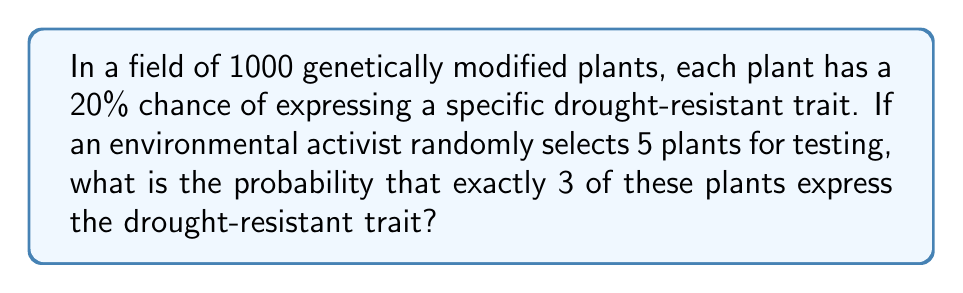Teach me how to tackle this problem. To solve this problem, we can use the binomial probability formula:

$$P(X = k) = \binom{n}{k} p^k (1-p)^{n-k}$$

Where:
$n$ = number of trials (plants selected) = 5
$k$ = number of successes (plants with the trait) = 3
$p$ = probability of success (expressing the trait) = 0.20

Step 1: Calculate the binomial coefficient $\binom{n}{k}$:
$$\binom{5}{3} = \frac{5!}{3!(5-3)!} = \frac{5 \cdot 4}{2 \cdot 1} = 10$$

Step 2: Calculate $p^k$:
$$0.20^3 = 0.008$$

Step 3: Calculate $(1-p)^{n-k}$:
$$(1-0.20)^{5-3} = 0.80^2 = 0.64$$

Step 4: Multiply all components:
$$10 \cdot 0.008 \cdot 0.64 = 0.0512$$

Therefore, the probability of selecting exactly 3 plants with the drought-resistant trait out of 5 randomly selected plants is 0.0512 or 5.12%.
Answer: 0.0512 